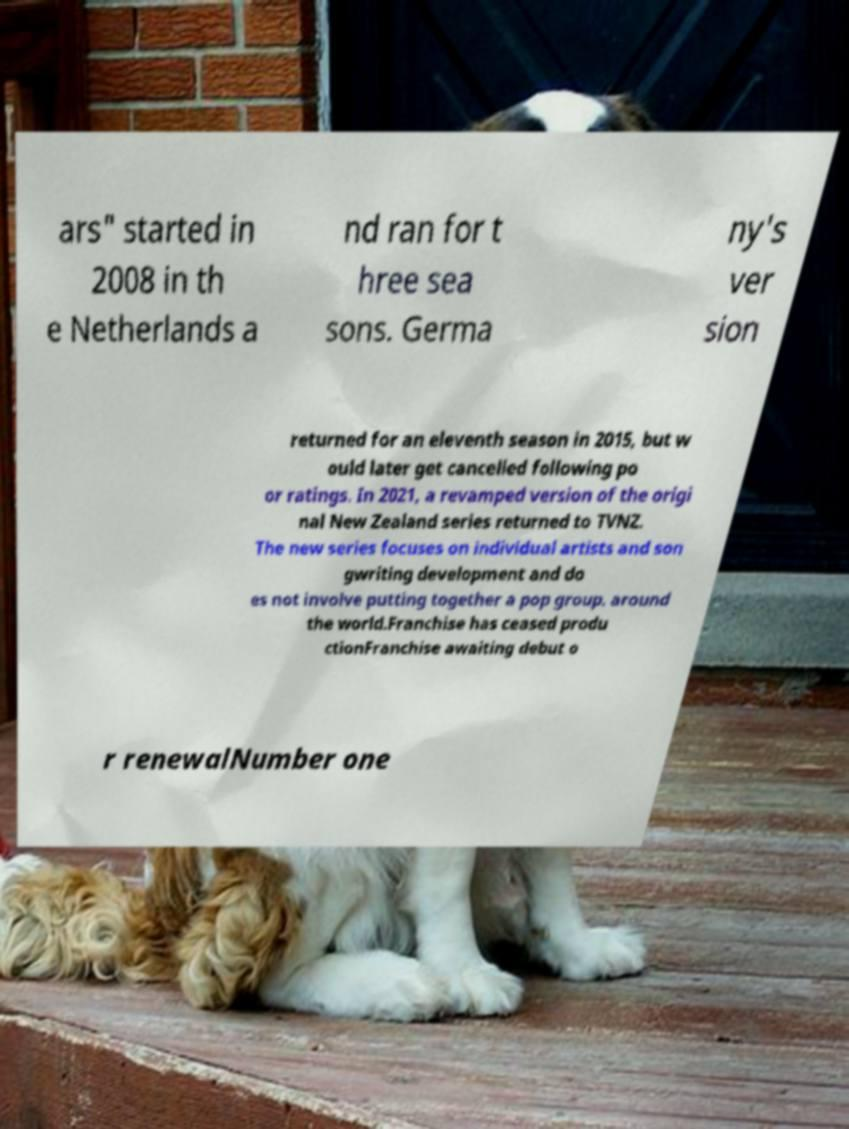Please identify and transcribe the text found in this image. ars" started in 2008 in th e Netherlands a nd ran for t hree sea sons. Germa ny's ver sion returned for an eleventh season in 2015, but w ould later get cancelled following po or ratings. In 2021, a revamped version of the origi nal New Zealand series returned to TVNZ. The new series focuses on individual artists and son gwriting development and do es not involve putting together a pop group. around the world.Franchise has ceased produ ctionFranchise awaiting debut o r renewalNumber one 